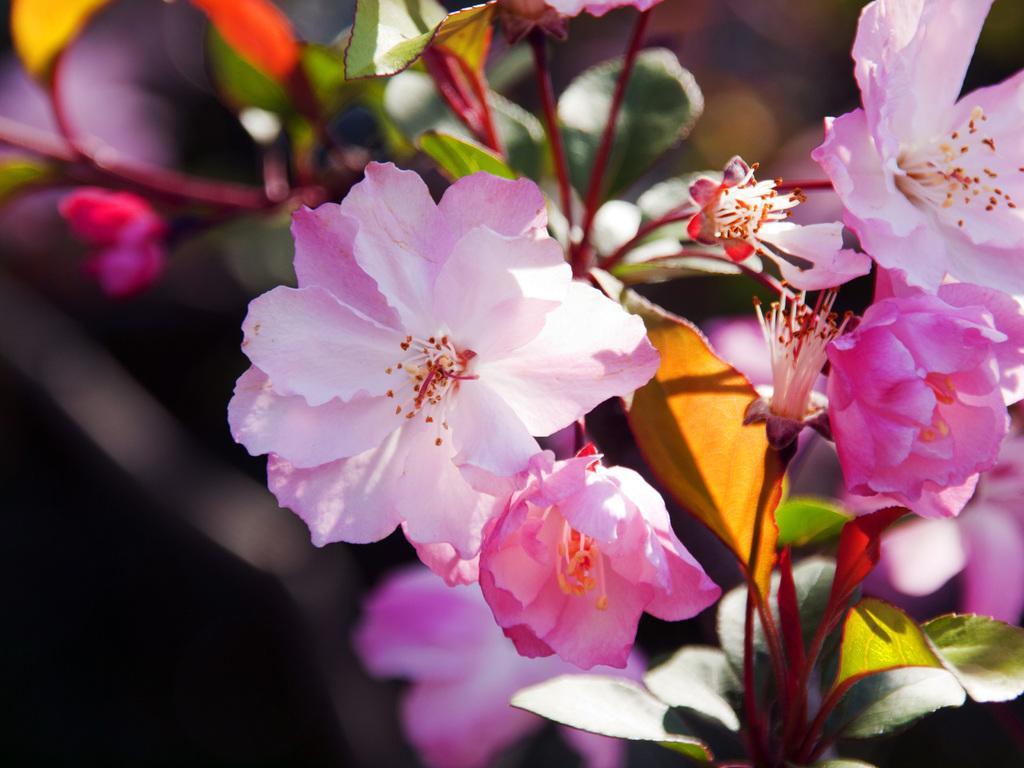In one or two sentences, can you explain what this image depicts? In this image we can see group of flowers and leaves on the stems of a plant. 